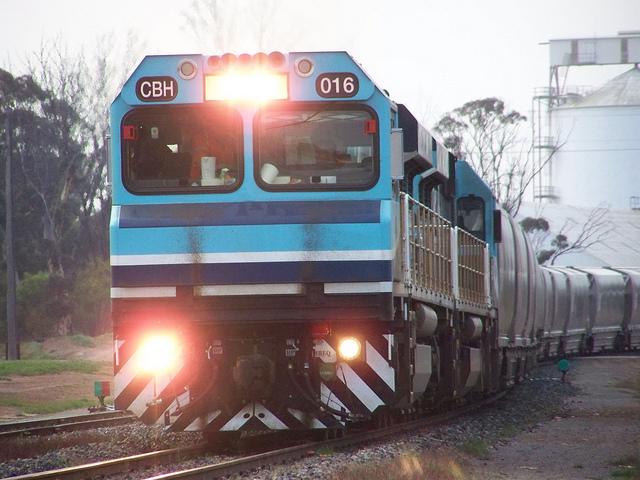Are these passenger trains?
Short answer required. Yes. Is there a number on the train?
Write a very short answer. Yes. What kind of transportation is this?
Write a very short answer. Train. Is this a passenger train?
Short answer required. Yes. What number is on the train on the right?
Answer briefly. 016. 